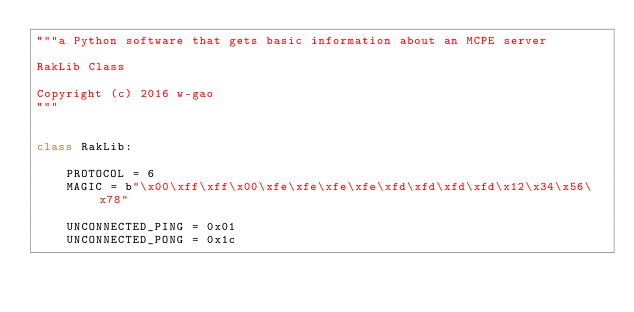Convert code to text. <code><loc_0><loc_0><loc_500><loc_500><_Python_>"""a Python software that gets basic information about an MCPE server

RakLib Class

Copyright (c) 2016 w-gao
"""


class RakLib:

    PROTOCOL = 6
    MAGIC = b"\x00\xff\xff\x00\xfe\xfe\xfe\xfe\xfd\xfd\xfd\xfd\x12\x34\x56\x78"

    UNCONNECTED_PING = 0x01
    UNCONNECTED_PONG = 0x1c
</code> 